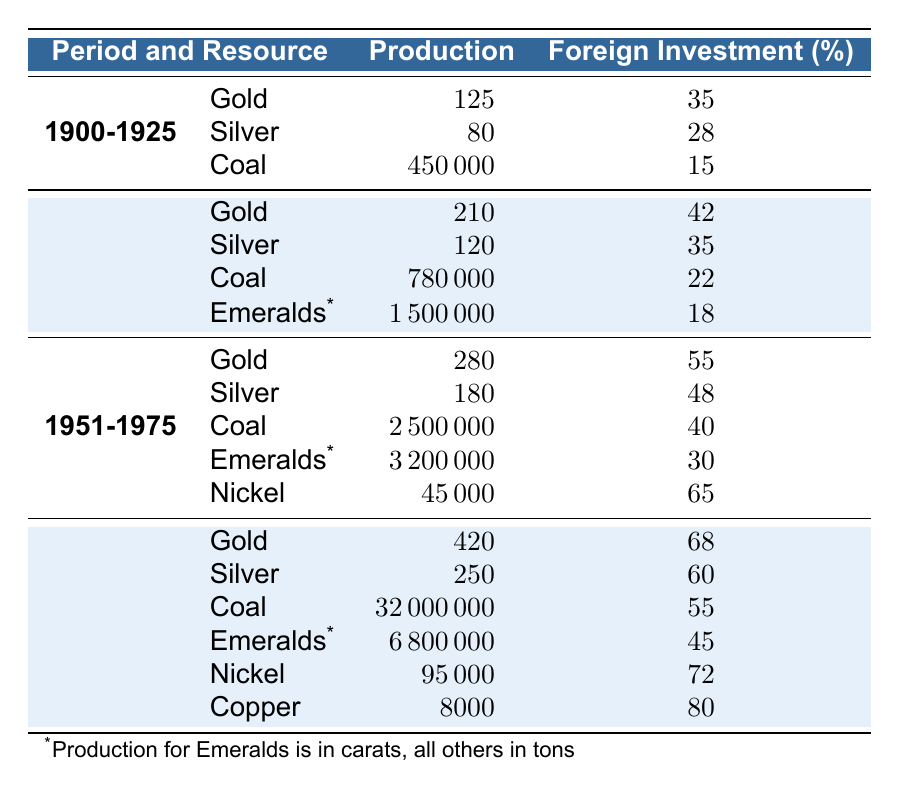What was the total production of coal from 1900 to 1925? The table shows that coal production for the period 1900-1925 is 450000 tons. Since there are no other periods involved in this calculation, the total production is simply this value.
Answer: 450000 tons What was the foreign investment percentage for emeralds in the period 1926-1950? Looking at the table, the foreign investment percentage for emeralds in the period 1926-1950 is 18%.
Answer: 18% Which resource had the highest foreign investment percentage in the period 1976-2000? Analyzing the data for the period 1976-2000: Gold had 68%, Silver had 60%, Coal had 55%, Emeralds had 45%, Nickel had 72%, and Copper had 80%. Copper had the highest percentage.
Answer: Copper with 80% What was the change in gold production from 1951-1975 to 1976-2000? Gold production in 1951-1975 was 280 tons and in 1976-2000 it was 420 tons. The change is 420 - 280 = 140 tons.
Answer: 140 tons Which resource had an increase in foreign investment percentage from the period 1951-1975 to 1976-2000? For Gold, the foreign investment percentages were 55% (1951-1975) and 68% (1976-2000); for Silver, it increased from 48% to 60%; for Coal, it increased from 40% to 55%; and for Nickel it increased from 65% to 72%. All these resources show an increase.
Answer: Gold, Silver, Coal, Nickel What was the average foreign investment percentage for coal production across all periods? The percentages for coal are 15%, 22%, 40%, and 55%. The average is calculated by (15 + 22 + 40 + 55) / 4 = 33%.
Answer: 33% Was the production of silver greater in the period 1926-1950 than in 1951-1975? Silver production was 120 tons in 1926-1950 and 180 tons in 1951-1975. Since 180 is greater than 120, the statement is true.
Answer: Yes What is the total production of emeralds for the periods listed? For emeralds, the production values are 1500000 carats (1926-1950) and 3200000 carats (1951-1975), and 6800000 carats (1976-2000). Adding these together: 1500000 + 3200000 + 6800000 = 11500000 carats.
Answer: 11500000 carats In which period was coal production the highest? The highest coal production value in the table is 32000000 tons, which occurs in the period from 1976 to 2000.
Answer: 1976-2000 What was the production of nickel in 1976-2000 compared to that of gold? Nickel production in 1976-2000 was 95000 tons, and gold production was 420 tons. Compared to gold, nickel production is significantly higher, as 95000 > 420.
Answer: Higher How much total silver was produced from 1900 to 2000? The silver production values are 80 tons (1900-1925), 120 tons (1926-1950), 180 tons (1951-1975), and 250 tons (1976-2000). Adding these yields: 80 + 120 + 180 + 250 = 630 tons.
Answer: 630 tons 